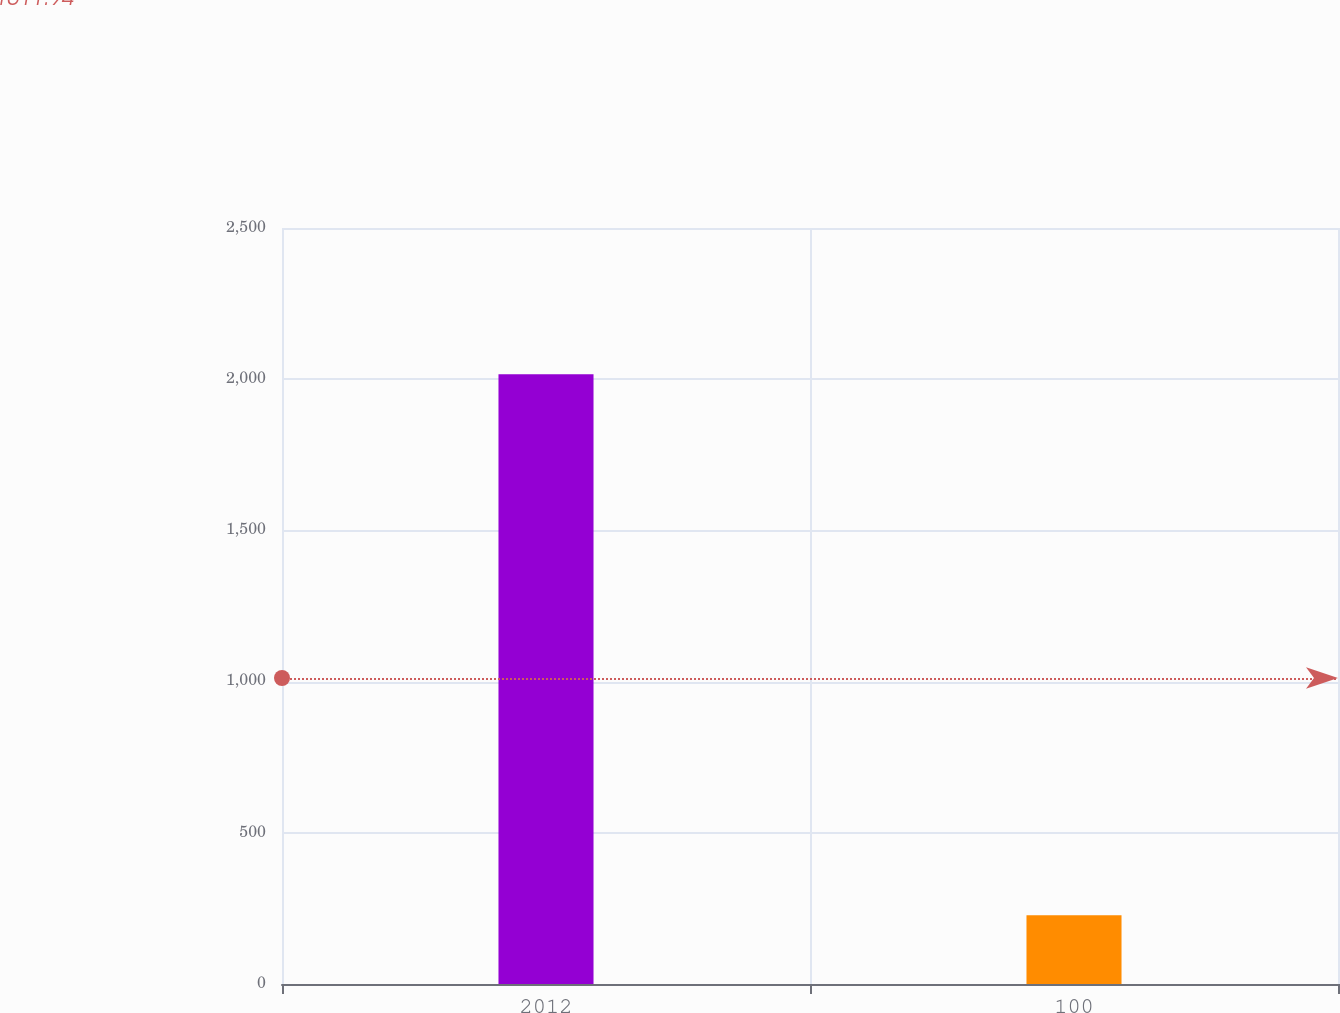Convert chart to OTSL. <chart><loc_0><loc_0><loc_500><loc_500><bar_chart><fcel>2012<fcel>100<nl><fcel>2016<fcel>227<nl></chart> 